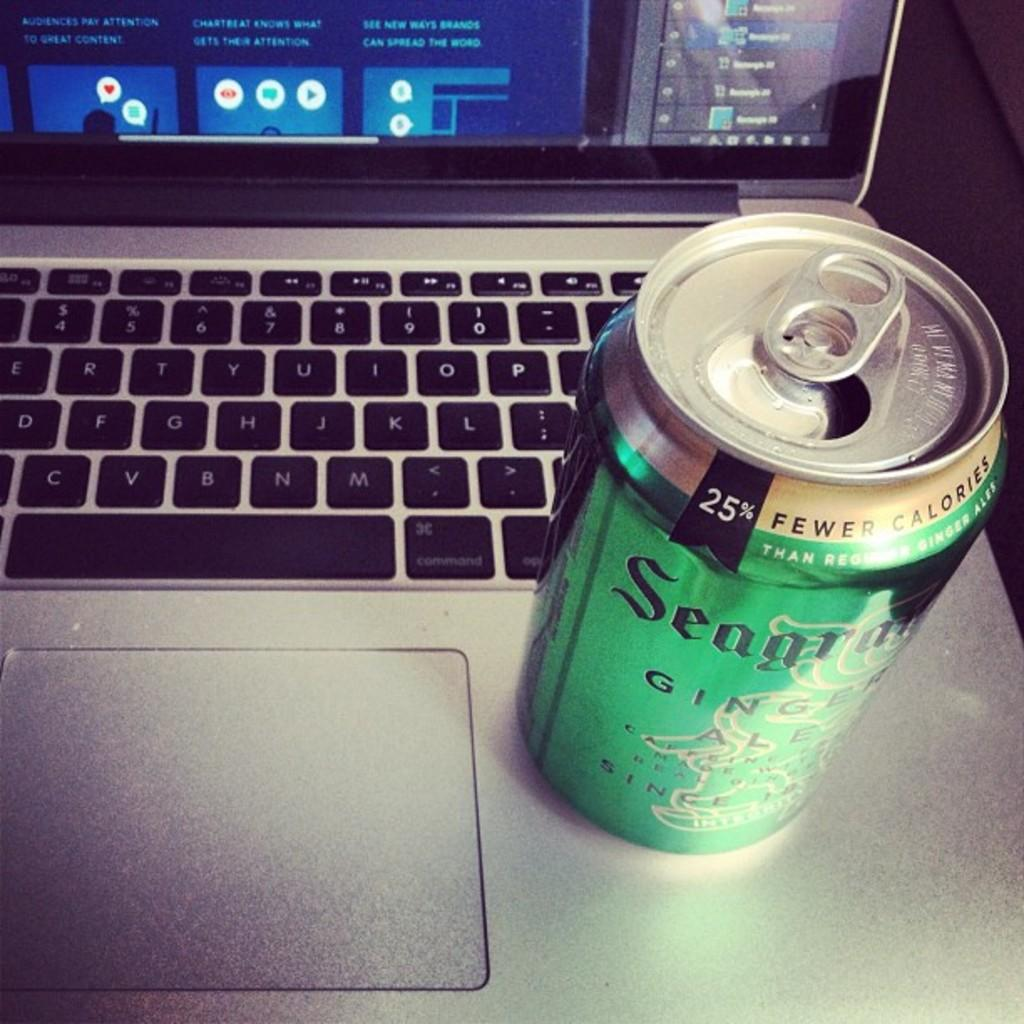<image>
Render a clear and concise summary of the photo. the word seagra that is on a can 